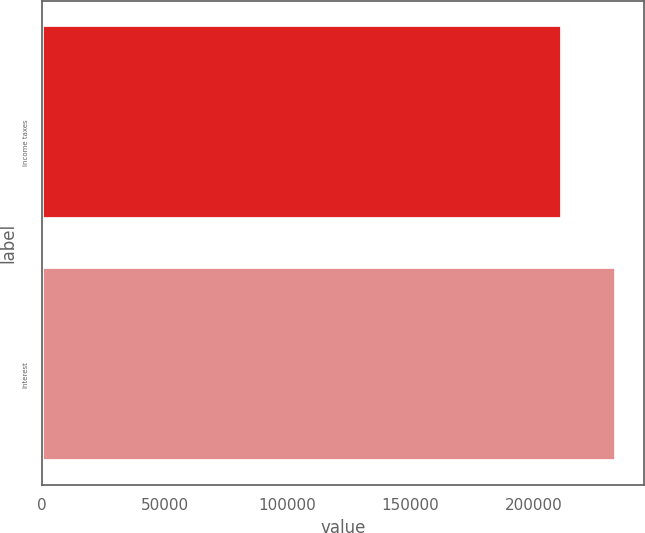Convert chart. <chart><loc_0><loc_0><loc_500><loc_500><bar_chart><fcel>Income taxes<fcel>Interest<nl><fcel>211473<fcel>233436<nl></chart> 